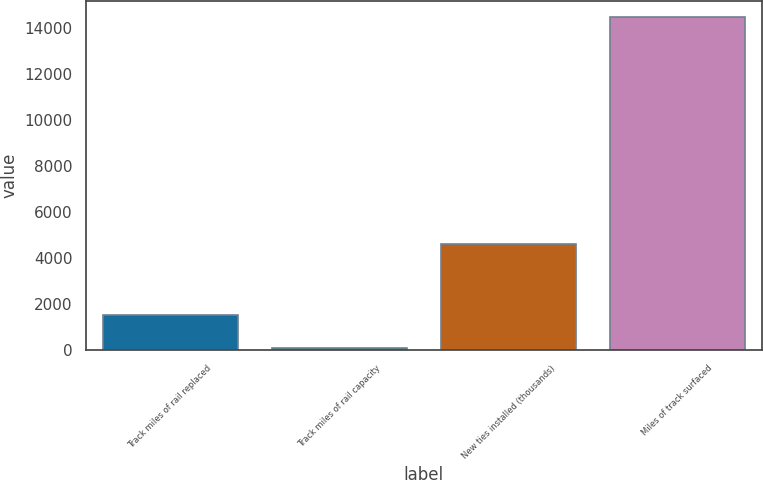Convert chart to OTSL. <chart><loc_0><loc_0><loc_500><loc_500><bar_chart><fcel>Track miles of rail replaced<fcel>Track miles of rail capacity<fcel>New ties installed (thousands)<fcel>Miles of track surfaced<nl><fcel>1551.6<fcel>118<fcel>4599<fcel>14454<nl></chart> 